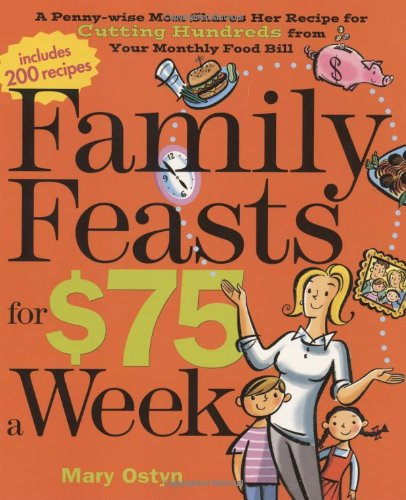What is the title of this book? The title of the book is 'Family Feasts for $75 a Week: A Penny-wise Mom Shares Her Recipe for Cutting Hundreds from Your Monthly Food Bill', indicating its focus on budget-friendly family meals. 